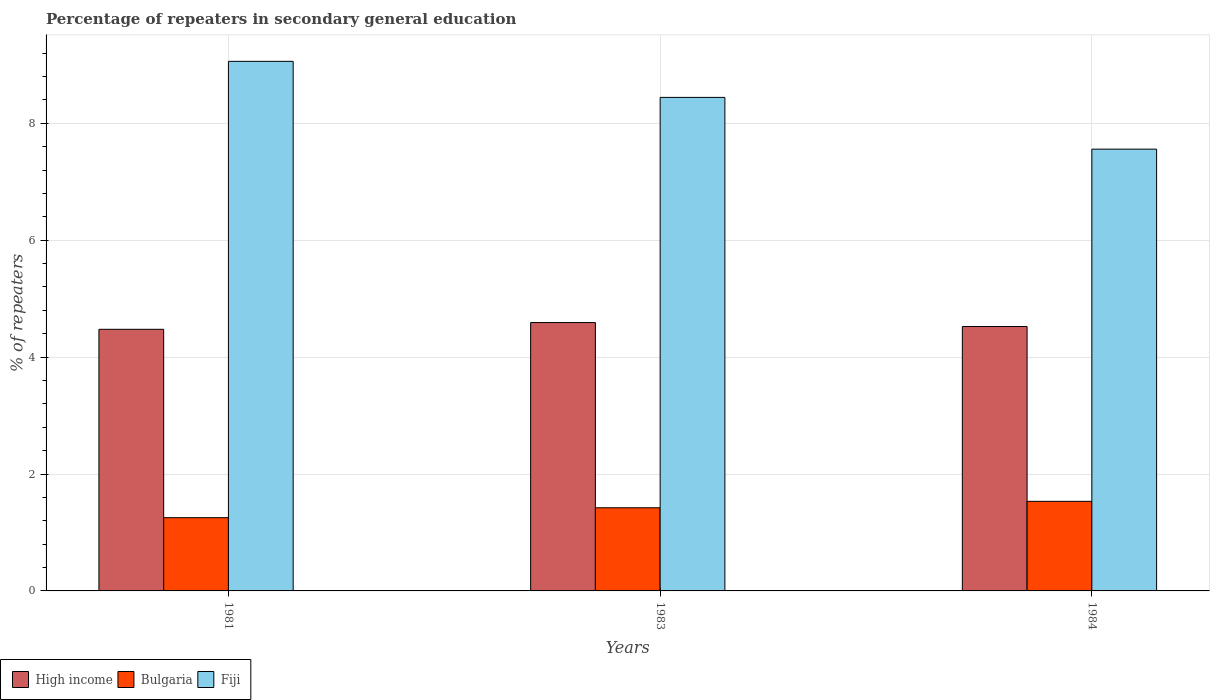How many different coloured bars are there?
Provide a succinct answer. 3. Are the number of bars per tick equal to the number of legend labels?
Keep it short and to the point. Yes. How many bars are there on the 1st tick from the right?
Give a very brief answer. 3. What is the percentage of repeaters in secondary general education in Fiji in 1983?
Offer a very short reply. 8.44. Across all years, what is the maximum percentage of repeaters in secondary general education in High income?
Keep it short and to the point. 4.59. Across all years, what is the minimum percentage of repeaters in secondary general education in Bulgaria?
Offer a very short reply. 1.25. In which year was the percentage of repeaters in secondary general education in Fiji minimum?
Your response must be concise. 1984. What is the total percentage of repeaters in secondary general education in High income in the graph?
Make the answer very short. 13.59. What is the difference between the percentage of repeaters in secondary general education in Bulgaria in 1983 and that in 1984?
Ensure brevity in your answer.  -0.11. What is the difference between the percentage of repeaters in secondary general education in Fiji in 1981 and the percentage of repeaters in secondary general education in Bulgaria in 1983?
Your answer should be compact. 7.64. What is the average percentage of repeaters in secondary general education in Bulgaria per year?
Provide a short and direct response. 1.4. In the year 1984, what is the difference between the percentage of repeaters in secondary general education in Fiji and percentage of repeaters in secondary general education in Bulgaria?
Ensure brevity in your answer.  6.03. What is the ratio of the percentage of repeaters in secondary general education in Fiji in 1983 to that in 1984?
Keep it short and to the point. 1.12. Is the difference between the percentage of repeaters in secondary general education in Fiji in 1981 and 1983 greater than the difference between the percentage of repeaters in secondary general education in Bulgaria in 1981 and 1983?
Offer a very short reply. Yes. What is the difference between the highest and the second highest percentage of repeaters in secondary general education in High income?
Ensure brevity in your answer.  0.07. What is the difference between the highest and the lowest percentage of repeaters in secondary general education in Bulgaria?
Make the answer very short. 0.28. What does the 1st bar from the left in 1983 represents?
Give a very brief answer. High income. What does the 2nd bar from the right in 1984 represents?
Your answer should be compact. Bulgaria. Is it the case that in every year, the sum of the percentage of repeaters in secondary general education in High income and percentage of repeaters in secondary general education in Fiji is greater than the percentage of repeaters in secondary general education in Bulgaria?
Your response must be concise. Yes. How many bars are there?
Your answer should be very brief. 9. Are all the bars in the graph horizontal?
Make the answer very short. No. What is the difference between two consecutive major ticks on the Y-axis?
Ensure brevity in your answer.  2. Does the graph contain any zero values?
Your answer should be compact. No. Does the graph contain grids?
Give a very brief answer. Yes. How are the legend labels stacked?
Offer a terse response. Horizontal. What is the title of the graph?
Provide a succinct answer. Percentage of repeaters in secondary general education. What is the label or title of the X-axis?
Offer a terse response. Years. What is the label or title of the Y-axis?
Your answer should be compact. % of repeaters. What is the % of repeaters in High income in 1981?
Provide a short and direct response. 4.48. What is the % of repeaters in Bulgaria in 1981?
Provide a short and direct response. 1.25. What is the % of repeaters in Fiji in 1981?
Your response must be concise. 9.06. What is the % of repeaters of High income in 1983?
Provide a short and direct response. 4.59. What is the % of repeaters of Bulgaria in 1983?
Your response must be concise. 1.42. What is the % of repeaters of Fiji in 1983?
Give a very brief answer. 8.44. What is the % of repeaters of High income in 1984?
Ensure brevity in your answer.  4.52. What is the % of repeaters of Bulgaria in 1984?
Offer a terse response. 1.53. What is the % of repeaters of Fiji in 1984?
Your answer should be compact. 7.56. Across all years, what is the maximum % of repeaters in High income?
Your response must be concise. 4.59. Across all years, what is the maximum % of repeaters of Bulgaria?
Your answer should be very brief. 1.53. Across all years, what is the maximum % of repeaters of Fiji?
Provide a short and direct response. 9.06. Across all years, what is the minimum % of repeaters in High income?
Give a very brief answer. 4.48. Across all years, what is the minimum % of repeaters of Bulgaria?
Your answer should be very brief. 1.25. Across all years, what is the minimum % of repeaters in Fiji?
Ensure brevity in your answer.  7.56. What is the total % of repeaters in High income in the graph?
Provide a short and direct response. 13.59. What is the total % of repeaters in Bulgaria in the graph?
Offer a terse response. 4.21. What is the total % of repeaters in Fiji in the graph?
Offer a terse response. 25.06. What is the difference between the % of repeaters of High income in 1981 and that in 1983?
Give a very brief answer. -0.12. What is the difference between the % of repeaters in Bulgaria in 1981 and that in 1983?
Provide a short and direct response. -0.17. What is the difference between the % of repeaters of Fiji in 1981 and that in 1983?
Offer a terse response. 0.62. What is the difference between the % of repeaters of High income in 1981 and that in 1984?
Keep it short and to the point. -0.05. What is the difference between the % of repeaters of Bulgaria in 1981 and that in 1984?
Provide a succinct answer. -0.28. What is the difference between the % of repeaters in Fiji in 1981 and that in 1984?
Provide a succinct answer. 1.5. What is the difference between the % of repeaters of High income in 1983 and that in 1984?
Provide a short and direct response. 0.07. What is the difference between the % of repeaters in Bulgaria in 1983 and that in 1984?
Provide a short and direct response. -0.11. What is the difference between the % of repeaters of Fiji in 1983 and that in 1984?
Your answer should be compact. 0.89. What is the difference between the % of repeaters in High income in 1981 and the % of repeaters in Bulgaria in 1983?
Provide a short and direct response. 3.05. What is the difference between the % of repeaters in High income in 1981 and the % of repeaters in Fiji in 1983?
Your answer should be very brief. -3.97. What is the difference between the % of repeaters in Bulgaria in 1981 and the % of repeaters in Fiji in 1983?
Ensure brevity in your answer.  -7.19. What is the difference between the % of repeaters in High income in 1981 and the % of repeaters in Bulgaria in 1984?
Give a very brief answer. 2.94. What is the difference between the % of repeaters in High income in 1981 and the % of repeaters in Fiji in 1984?
Give a very brief answer. -3.08. What is the difference between the % of repeaters in Bulgaria in 1981 and the % of repeaters in Fiji in 1984?
Provide a succinct answer. -6.31. What is the difference between the % of repeaters of High income in 1983 and the % of repeaters of Bulgaria in 1984?
Make the answer very short. 3.06. What is the difference between the % of repeaters of High income in 1983 and the % of repeaters of Fiji in 1984?
Provide a succinct answer. -2.97. What is the difference between the % of repeaters in Bulgaria in 1983 and the % of repeaters in Fiji in 1984?
Keep it short and to the point. -6.14. What is the average % of repeaters in High income per year?
Give a very brief answer. 4.53. What is the average % of repeaters of Bulgaria per year?
Ensure brevity in your answer.  1.4. What is the average % of repeaters of Fiji per year?
Provide a short and direct response. 8.35. In the year 1981, what is the difference between the % of repeaters of High income and % of repeaters of Bulgaria?
Keep it short and to the point. 3.22. In the year 1981, what is the difference between the % of repeaters of High income and % of repeaters of Fiji?
Make the answer very short. -4.58. In the year 1981, what is the difference between the % of repeaters in Bulgaria and % of repeaters in Fiji?
Give a very brief answer. -7.81. In the year 1983, what is the difference between the % of repeaters of High income and % of repeaters of Bulgaria?
Your answer should be compact. 3.17. In the year 1983, what is the difference between the % of repeaters in High income and % of repeaters in Fiji?
Make the answer very short. -3.85. In the year 1983, what is the difference between the % of repeaters in Bulgaria and % of repeaters in Fiji?
Your answer should be very brief. -7.02. In the year 1984, what is the difference between the % of repeaters of High income and % of repeaters of Bulgaria?
Your answer should be compact. 2.99. In the year 1984, what is the difference between the % of repeaters in High income and % of repeaters in Fiji?
Offer a very short reply. -3.03. In the year 1984, what is the difference between the % of repeaters in Bulgaria and % of repeaters in Fiji?
Make the answer very short. -6.03. What is the ratio of the % of repeaters of High income in 1981 to that in 1983?
Ensure brevity in your answer.  0.97. What is the ratio of the % of repeaters in Bulgaria in 1981 to that in 1983?
Offer a terse response. 0.88. What is the ratio of the % of repeaters of Fiji in 1981 to that in 1983?
Make the answer very short. 1.07. What is the ratio of the % of repeaters of Bulgaria in 1981 to that in 1984?
Keep it short and to the point. 0.82. What is the ratio of the % of repeaters in Fiji in 1981 to that in 1984?
Provide a short and direct response. 1.2. What is the ratio of the % of repeaters of High income in 1983 to that in 1984?
Offer a terse response. 1.01. What is the ratio of the % of repeaters of Bulgaria in 1983 to that in 1984?
Offer a very short reply. 0.93. What is the ratio of the % of repeaters of Fiji in 1983 to that in 1984?
Provide a succinct answer. 1.12. What is the difference between the highest and the second highest % of repeaters in High income?
Provide a succinct answer. 0.07. What is the difference between the highest and the second highest % of repeaters in Bulgaria?
Offer a terse response. 0.11. What is the difference between the highest and the second highest % of repeaters in Fiji?
Make the answer very short. 0.62. What is the difference between the highest and the lowest % of repeaters of High income?
Your response must be concise. 0.12. What is the difference between the highest and the lowest % of repeaters in Bulgaria?
Ensure brevity in your answer.  0.28. What is the difference between the highest and the lowest % of repeaters of Fiji?
Give a very brief answer. 1.5. 